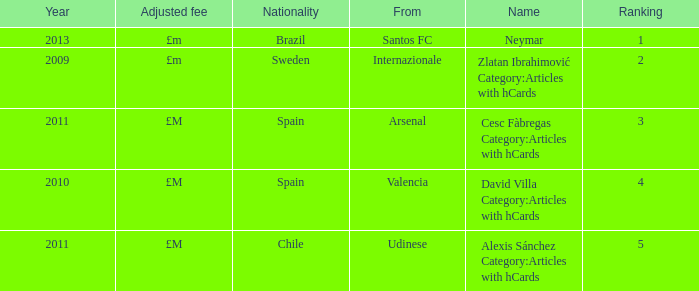What is the name of the player from Spain with a rank lower than 3? David Villa Category:Articles with hCards. 